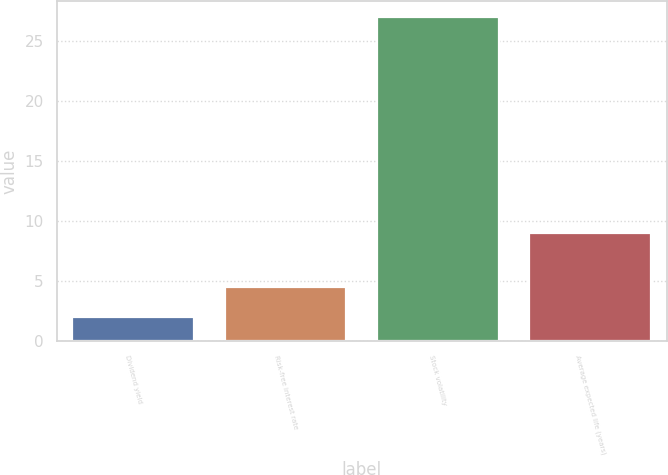Convert chart. <chart><loc_0><loc_0><loc_500><loc_500><bar_chart><fcel>Dividend yield<fcel>Risk-free interest rate<fcel>Stock volatility<fcel>Average expected life (years)<nl><fcel>2<fcel>4.5<fcel>27<fcel>9<nl></chart> 